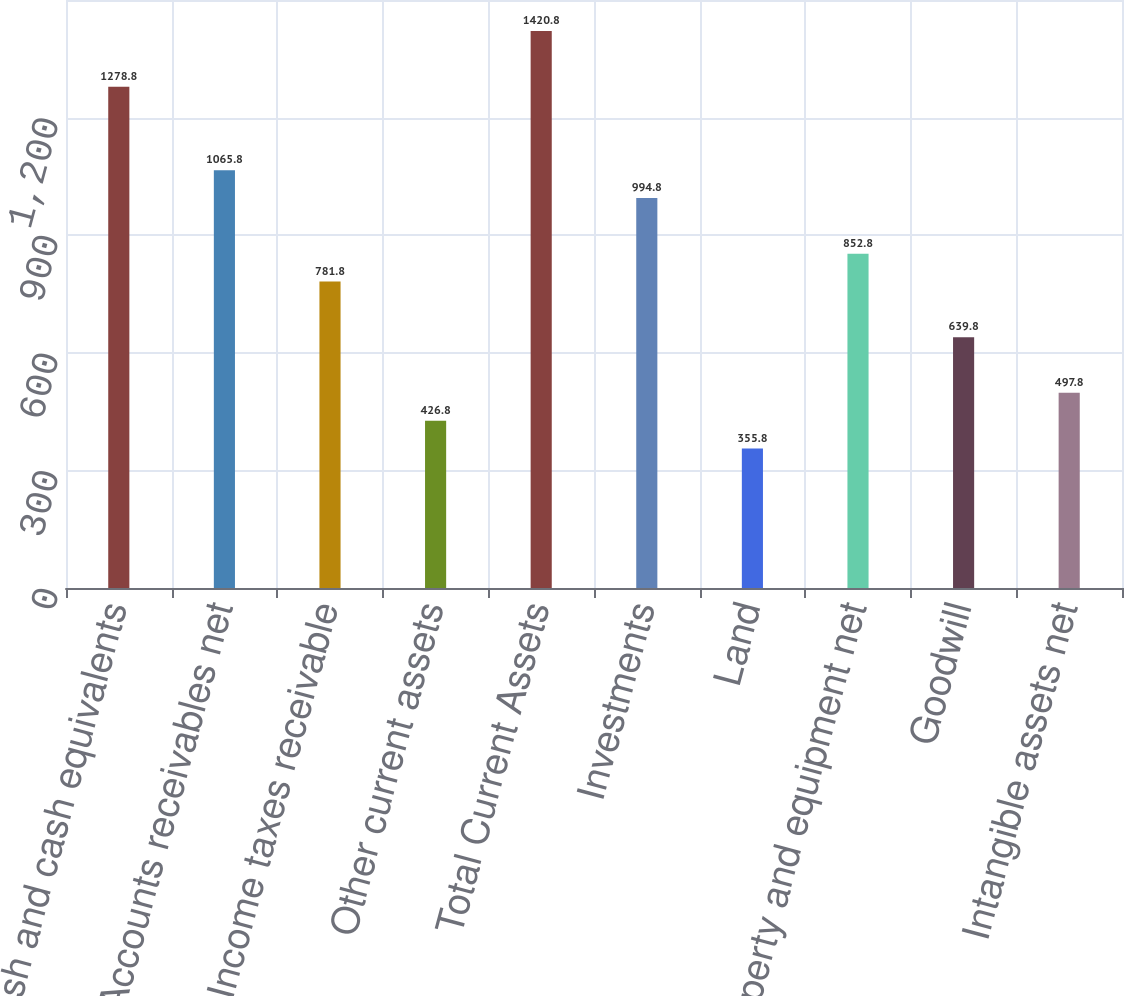Convert chart. <chart><loc_0><loc_0><loc_500><loc_500><bar_chart><fcel>Cash and cash equivalents<fcel>Accounts receivables net<fcel>Income taxes receivable<fcel>Other current assets<fcel>Total Current Assets<fcel>Investments<fcel>Land<fcel>Property and equipment net<fcel>Goodwill<fcel>Intangible assets net<nl><fcel>1278.8<fcel>1065.8<fcel>781.8<fcel>426.8<fcel>1420.8<fcel>994.8<fcel>355.8<fcel>852.8<fcel>639.8<fcel>497.8<nl></chart> 